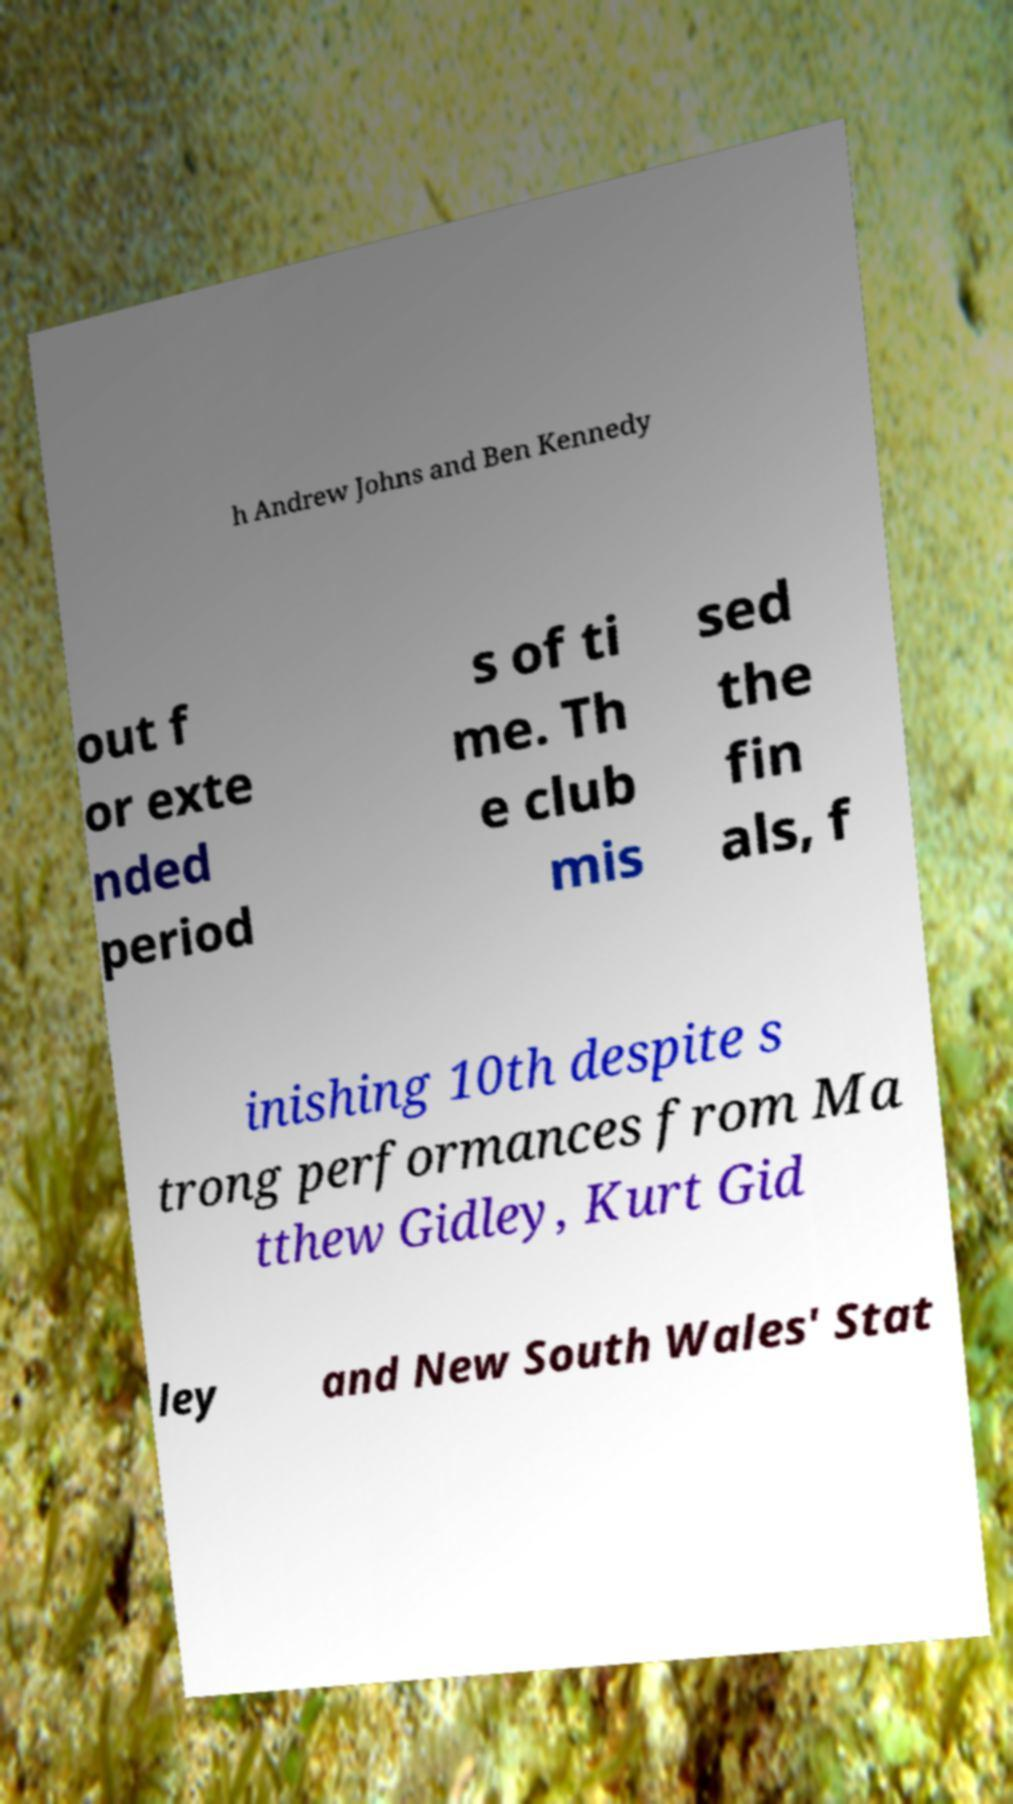Can you accurately transcribe the text from the provided image for me? h Andrew Johns and Ben Kennedy out f or exte nded period s of ti me. Th e club mis sed the fin als, f inishing 10th despite s trong performances from Ma tthew Gidley, Kurt Gid ley and New South Wales' Stat 